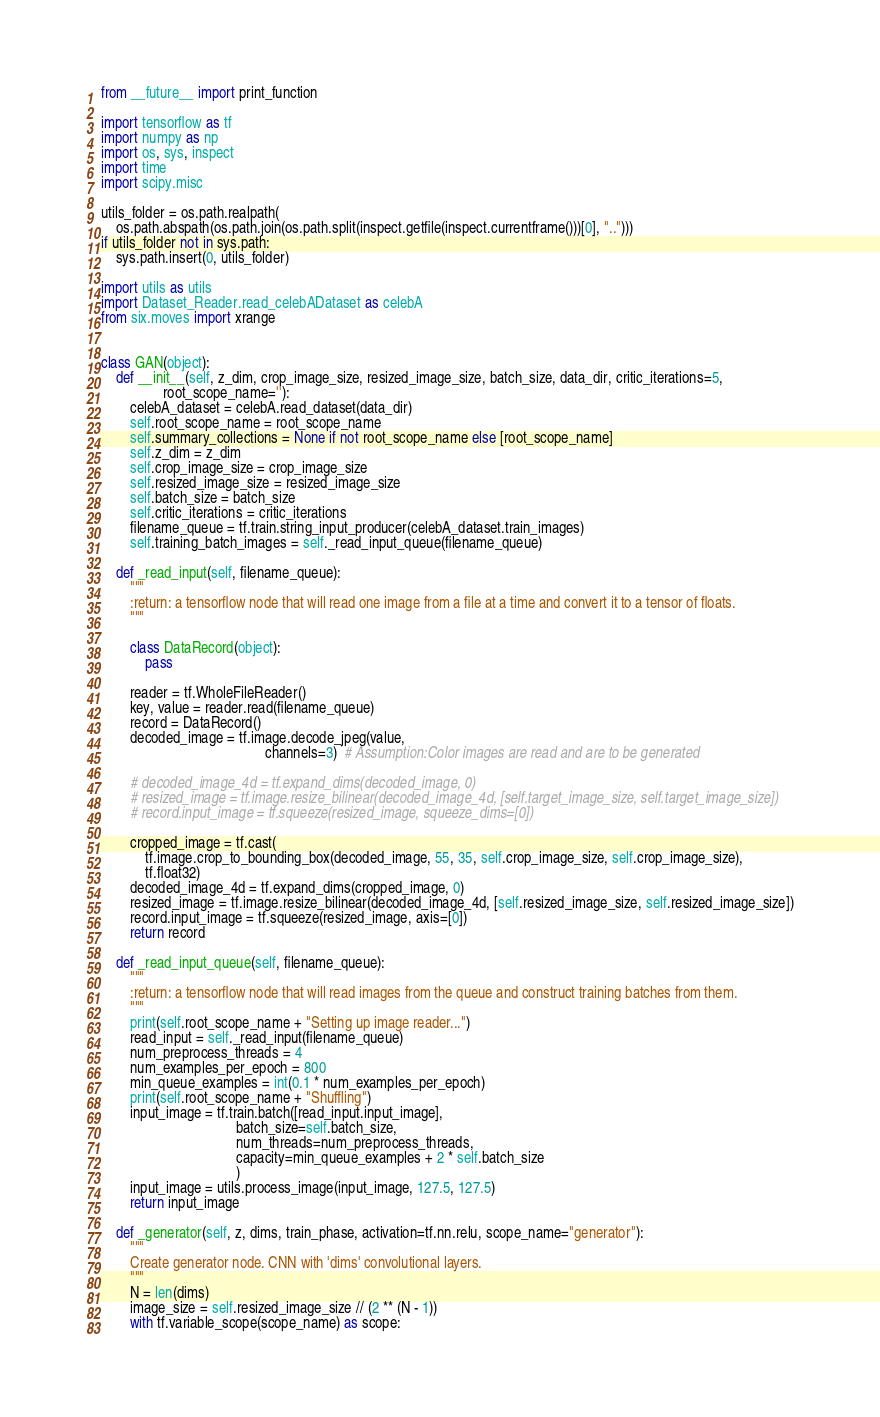<code> <loc_0><loc_0><loc_500><loc_500><_Python_>from __future__ import print_function

import tensorflow as tf
import numpy as np
import os, sys, inspect
import time
import scipy.misc

utils_folder = os.path.realpath(
    os.path.abspath(os.path.join(os.path.split(inspect.getfile(inspect.currentframe()))[0], "..")))
if utils_folder not in sys.path:
    sys.path.insert(0, utils_folder)

import utils as utils
import Dataset_Reader.read_celebADataset as celebA
from six.moves import xrange


class GAN(object):
    def __init__(self, z_dim, crop_image_size, resized_image_size, batch_size, data_dir, critic_iterations=5,
                 root_scope_name=''):
        celebA_dataset = celebA.read_dataset(data_dir)
        self.root_scope_name = root_scope_name
        self.summary_collections = None if not root_scope_name else [root_scope_name]
        self.z_dim = z_dim
        self.crop_image_size = crop_image_size
        self.resized_image_size = resized_image_size
        self.batch_size = batch_size
        self.critic_iterations = critic_iterations
        filename_queue = tf.train.string_input_producer(celebA_dataset.train_images)
        self.training_batch_images = self._read_input_queue(filename_queue)

    def _read_input(self, filename_queue):
        """
        :return: a tensorflow node that will read one image from a file at a time and convert it to a tensor of floats.
        """

        class DataRecord(object):
            pass

        reader = tf.WholeFileReader()
        key, value = reader.read(filename_queue)
        record = DataRecord()
        decoded_image = tf.image.decode_jpeg(value,
                                             channels=3)  # Assumption:Color images are read and are to be generated

        # decoded_image_4d = tf.expand_dims(decoded_image, 0)
        # resized_image = tf.image.resize_bilinear(decoded_image_4d, [self.target_image_size, self.target_image_size])
        # record.input_image = tf.squeeze(resized_image, squeeze_dims=[0])

        cropped_image = tf.cast(
            tf.image.crop_to_bounding_box(decoded_image, 55, 35, self.crop_image_size, self.crop_image_size),
            tf.float32)
        decoded_image_4d = tf.expand_dims(cropped_image, 0)
        resized_image = tf.image.resize_bilinear(decoded_image_4d, [self.resized_image_size, self.resized_image_size])
        record.input_image = tf.squeeze(resized_image, axis=[0])
        return record

    def _read_input_queue(self, filename_queue):
        """
        :return: a tensorflow node that will read images from the queue and construct training batches from them.
        """
        print(self.root_scope_name + "Setting up image reader...")
        read_input = self._read_input(filename_queue)
        num_preprocess_threads = 4
        num_examples_per_epoch = 800
        min_queue_examples = int(0.1 * num_examples_per_epoch)
        print(self.root_scope_name + "Shuffling")
        input_image = tf.train.batch([read_input.input_image],
                                     batch_size=self.batch_size,
                                     num_threads=num_preprocess_threads,
                                     capacity=min_queue_examples + 2 * self.batch_size
                                     )
        input_image = utils.process_image(input_image, 127.5, 127.5)
        return input_image

    def _generator(self, z, dims, train_phase, activation=tf.nn.relu, scope_name="generator"):
        """
        Create generator node. CNN with 'dims' convolutional layers.
        """
        N = len(dims)
        image_size = self.resized_image_size // (2 ** (N - 1))
        with tf.variable_scope(scope_name) as scope:</code> 